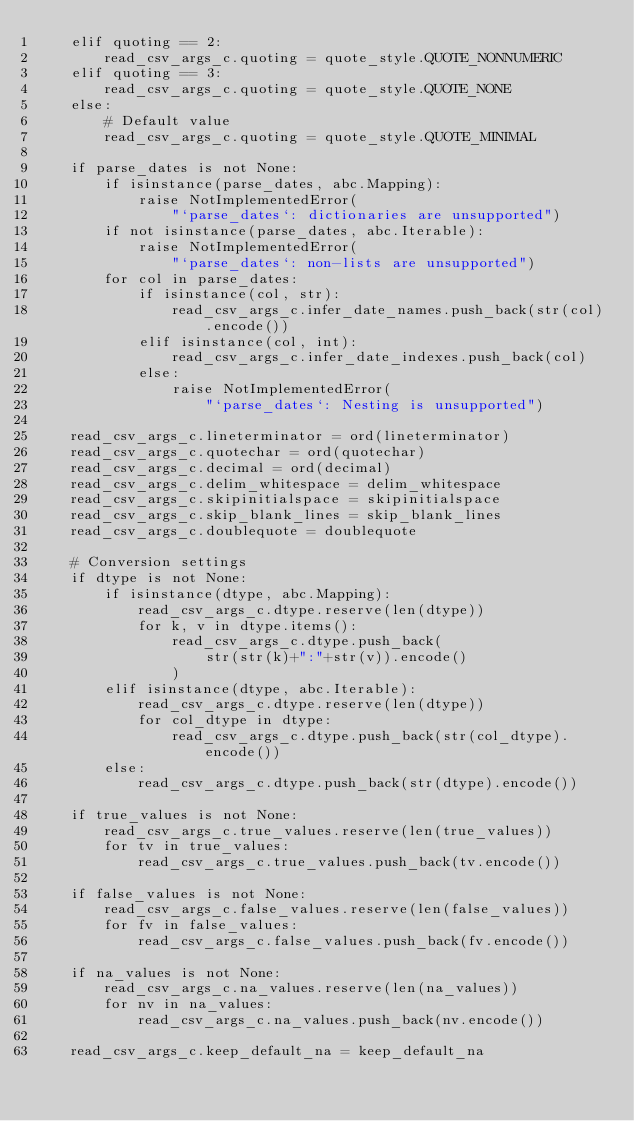Convert code to text. <code><loc_0><loc_0><loc_500><loc_500><_Cython_>    elif quoting == 2:
        read_csv_args_c.quoting = quote_style.QUOTE_NONNUMERIC
    elif quoting == 3:
        read_csv_args_c.quoting = quote_style.QUOTE_NONE
    else:
        # Default value
        read_csv_args_c.quoting = quote_style.QUOTE_MINIMAL

    if parse_dates is not None:
        if isinstance(parse_dates, abc.Mapping):
            raise NotImplementedError(
                "`parse_dates`: dictionaries are unsupported")
        if not isinstance(parse_dates, abc.Iterable):
            raise NotImplementedError(
                "`parse_dates`: non-lists are unsupported")
        for col in parse_dates:
            if isinstance(col, str):
                read_csv_args_c.infer_date_names.push_back(str(col).encode())
            elif isinstance(col, int):
                read_csv_args_c.infer_date_indexes.push_back(col)
            else:
                raise NotImplementedError(
                    "`parse_dates`: Nesting is unsupported")

    read_csv_args_c.lineterminator = ord(lineterminator)
    read_csv_args_c.quotechar = ord(quotechar)
    read_csv_args_c.decimal = ord(decimal)
    read_csv_args_c.delim_whitespace = delim_whitespace
    read_csv_args_c.skipinitialspace = skipinitialspace
    read_csv_args_c.skip_blank_lines = skip_blank_lines
    read_csv_args_c.doublequote = doublequote

    # Conversion settings
    if dtype is not None:
        if isinstance(dtype, abc.Mapping):
            read_csv_args_c.dtype.reserve(len(dtype))
            for k, v in dtype.items():
                read_csv_args_c.dtype.push_back(
                    str(str(k)+":"+str(v)).encode()
                )
        elif isinstance(dtype, abc.Iterable):
            read_csv_args_c.dtype.reserve(len(dtype))
            for col_dtype in dtype:
                read_csv_args_c.dtype.push_back(str(col_dtype).encode())
        else:
            read_csv_args_c.dtype.push_back(str(dtype).encode())

    if true_values is not None:
        read_csv_args_c.true_values.reserve(len(true_values))
        for tv in true_values:
            read_csv_args_c.true_values.push_back(tv.encode())

    if false_values is not None:
        read_csv_args_c.false_values.reserve(len(false_values))
        for fv in false_values:
            read_csv_args_c.false_values.push_back(fv.encode())

    if na_values is not None:
        read_csv_args_c.na_values.reserve(len(na_values))
        for nv in na_values:
            read_csv_args_c.na_values.push_back(nv.encode())

    read_csv_args_c.keep_default_na = keep_default_na</code> 